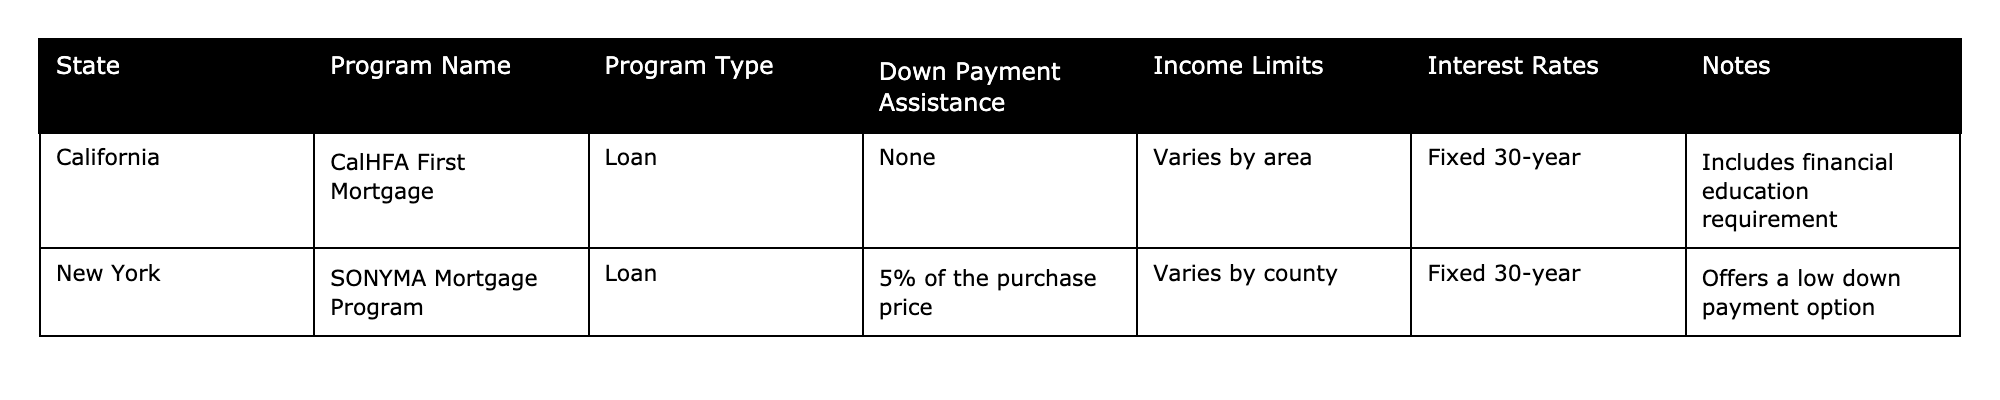What type of program is available in California for first-time homebuyers? The table indicates that California offers the "CalHFA First Mortgage," which is classified as a loan program.
Answer: Loan Is there any down payment assistance provided by the CalHFA program? The table specifies that the CalHFA First Mortgage does not provide any down payment assistance ("None").
Answer: None What are the income limits for the SONYMA Mortgage Program in New York? The table notes that income limits for this program vary by county but does not provide specific numeric values.
Answer: Varies by county What is the maximum down payment assistance provided by the SONYMA Mortgage Program? According to the table, the maximum down payment assistance available through this program is 5% of the purchase price.
Answer: 5% Which state has a financial education requirement as part of its mortgage assistance program? The table indicates that California's CalHFA First Mortgage includes a financial education requirement.
Answer: California Are the interest rates fixed for both programs listed in the table? The table indicates that both programs offer a fixed 30-year interest rate, confirming they are fixed.
Answer: Yes If a homebuyer in California wants to utilize the CalHFA loan, what is the requirement regarding down payment assistance? The table shows that the CalHFA First Mortgage does not provide down payment assistance, implying no specific requirement exists for it.
Answer: None Which program offers low down payment options, and in which state is it available? The SONYMA Mortgage Program in New York offers a low down payment option, as stated in the table.
Answer: SONYMA Mortgage Program in New York What differentiates the CalHFA First Mortgage from the SONYMA Mortgage Program in terms of down payment assistance? The CalHFA program offers no down payment assistance while the SONYMA program provides up to 5% of the purchase price, showcasing a key difference.
Answer: CalHFA: None, SONYMA: 5% Can first-time homebuyers in New York take advantage of a fixed interest rate through any program listed? The table states that the SONYMA Mortgage Program provides a fixed 30-year interest rate, confirming its availability for homebuyers.
Answer: Yes 